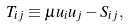Convert formula to latex. <formula><loc_0><loc_0><loc_500><loc_500>T _ { i j } \equiv \mu u _ { i } u _ { j } - S _ { i j } ,</formula> 